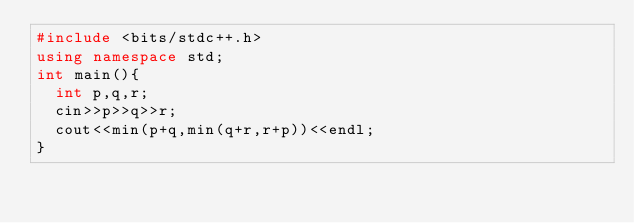<code> <loc_0><loc_0><loc_500><loc_500><_C++_>#include <bits/stdc++.h>
using namespace std;
int main(){
  int p,q,r;
  cin>>p>>q>>r;
  cout<<min(p+q,min(q+r,r+p))<<endl;
}</code> 